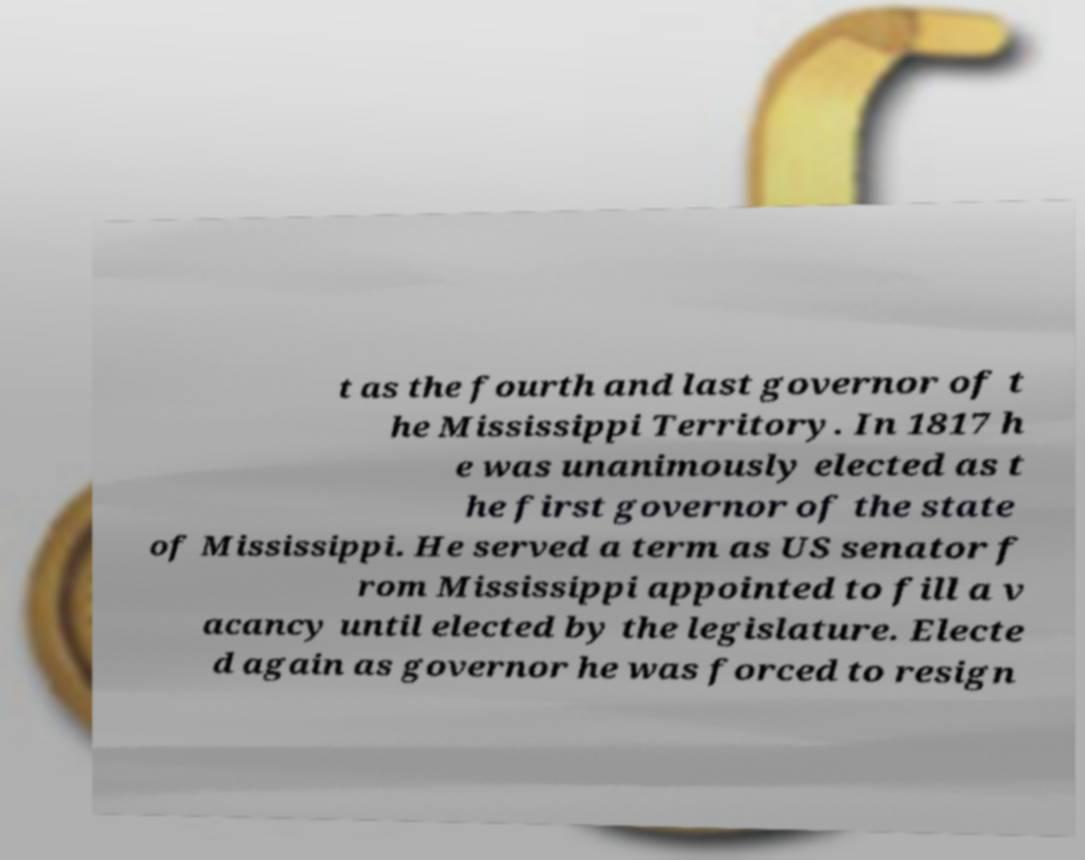Please identify and transcribe the text found in this image. t as the fourth and last governor of t he Mississippi Territory. In 1817 h e was unanimously elected as t he first governor of the state of Mississippi. He served a term as US senator f rom Mississippi appointed to fill a v acancy until elected by the legislature. Electe d again as governor he was forced to resign 